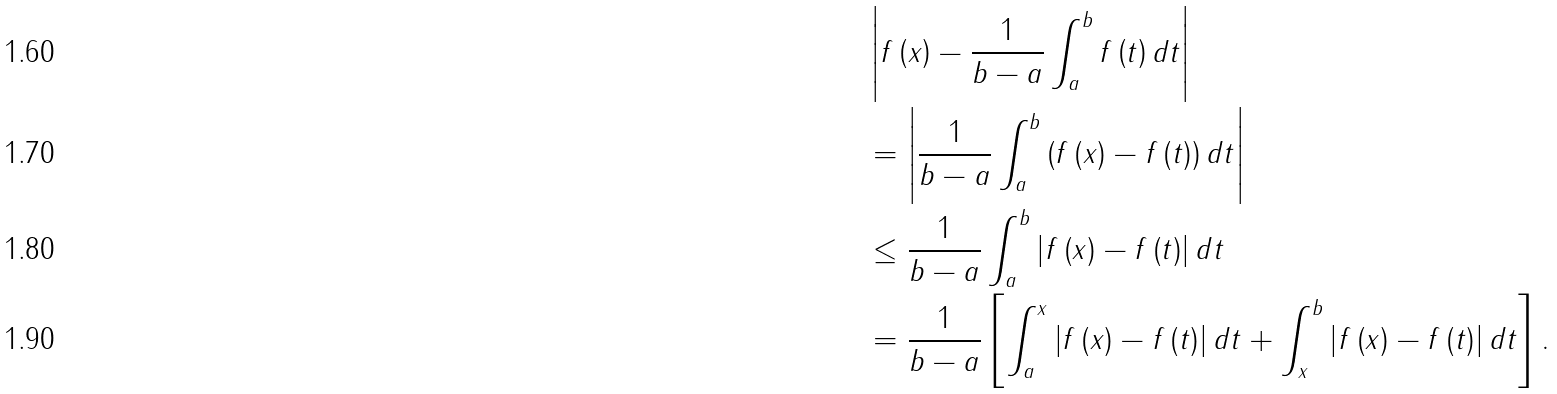Convert formula to latex. <formula><loc_0><loc_0><loc_500><loc_500>& \left | f \left ( x \right ) - \frac { 1 } { b - a } \int _ { a } ^ { b } f \left ( t \right ) d t \right | \\ & = \left | \frac { 1 } { b - a } \int _ { a } ^ { b } \left ( f \left ( x \right ) - f \left ( t \right ) \right ) d t \right | \\ & \leq \frac { 1 } { b - a } \int _ { a } ^ { b } \left | f \left ( x \right ) - f \left ( t \right ) \right | d t \\ & = \frac { 1 } { b - a } \left [ \int _ { a } ^ { x } \left | f \left ( x \right ) - f \left ( t \right ) \right | d t + \int _ { x } ^ { b } \left | f \left ( x \right ) - f \left ( t \right ) \right | d t \right ] .</formula> 